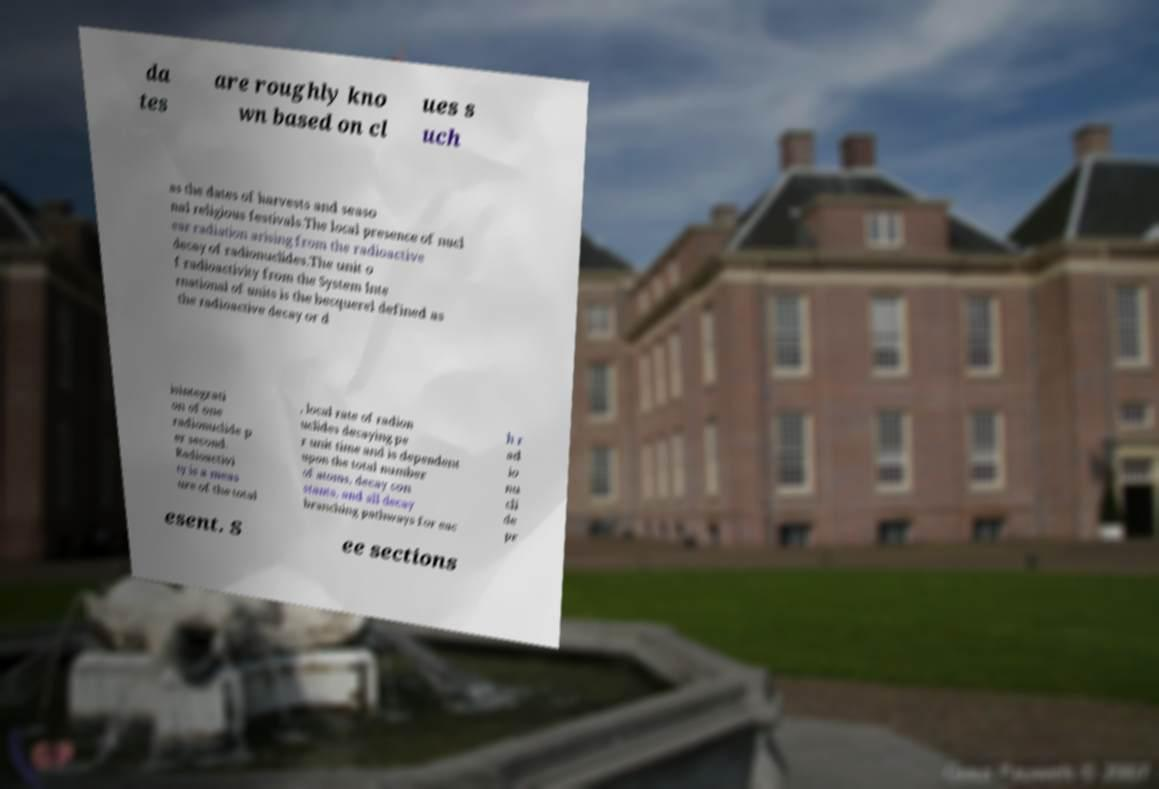There's text embedded in this image that I need extracted. Can you transcribe it verbatim? da tes are roughly kno wn based on cl ues s uch as the dates of harvests and seaso nal religious festivals.The local presence of nucl ear radiation arising from the radioactive decay of radionuclides.The unit o f radioactivity from the System Inte rnational of units is the becquerel defined as the radioactive decay or d isintegrati on of one radionuclide p er second. Radioactivi ty is a meas ure of the total , local rate of radion uclides decaying pe r unit time and is dependent upon the total number of atoms, decay con stants, and all decay branching pathways for eac h r ad io nu cli de pr esent. S ee sections 